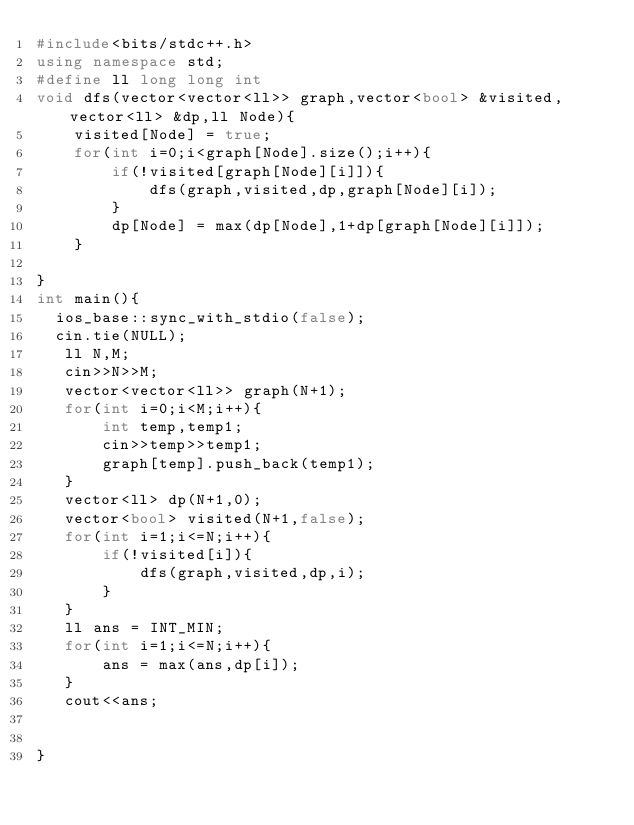Convert code to text. <code><loc_0><loc_0><loc_500><loc_500><_C++_>#include<bits/stdc++.h>
using namespace std;
#define ll long long int
void dfs(vector<vector<ll>> graph,vector<bool> &visited,vector<ll> &dp,ll Node){
    visited[Node] = true;
    for(int i=0;i<graph[Node].size();i++){
        if(!visited[graph[Node][i]]){
            dfs(graph,visited,dp,graph[Node][i]);
        }
        dp[Node] = max(dp[Node],1+dp[graph[Node][i]]);
    }
    
}
int main(){
  ios_base::sync_with_stdio(false);
  cin.tie(NULL);
   ll N,M;
   cin>>N>>M;
   vector<vector<ll>> graph(N+1);
   for(int i=0;i<M;i++){
       int temp,temp1;
       cin>>temp>>temp1;
       graph[temp].push_back(temp1);
   }
   vector<ll> dp(N+1,0);
   vector<bool> visited(N+1,false);
   for(int i=1;i<=N;i++){
       if(!visited[i]){
           dfs(graph,visited,dp,i);
       }
   }
   ll ans = INT_MIN;
   for(int i=1;i<=N;i++){
       ans = max(ans,dp[i]);
   }
   cout<<ans;
   
  
}</code> 